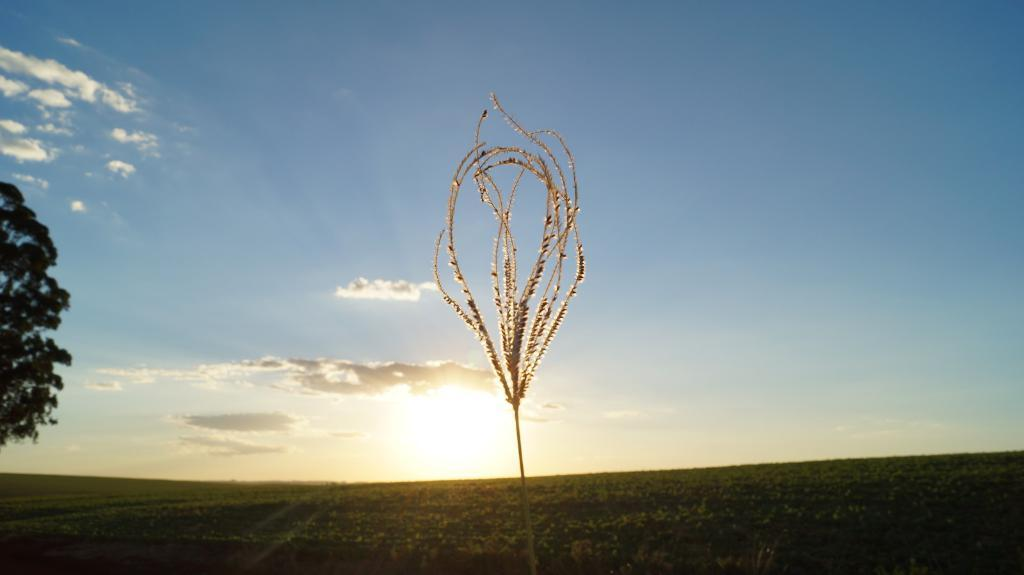What type of vegetation is present in the image? There is a plant and a tree in the image. What celestial body is visible in the image? The sun is visible in the image. What is the condition of the sky in the image? The sky is cloudy in the image. What type of bone is visible in the image? There is no bone present in the image. What type of skirt is hanging on the tree in the image? There is no skirt present in the image; it only features a plant and a tree. 